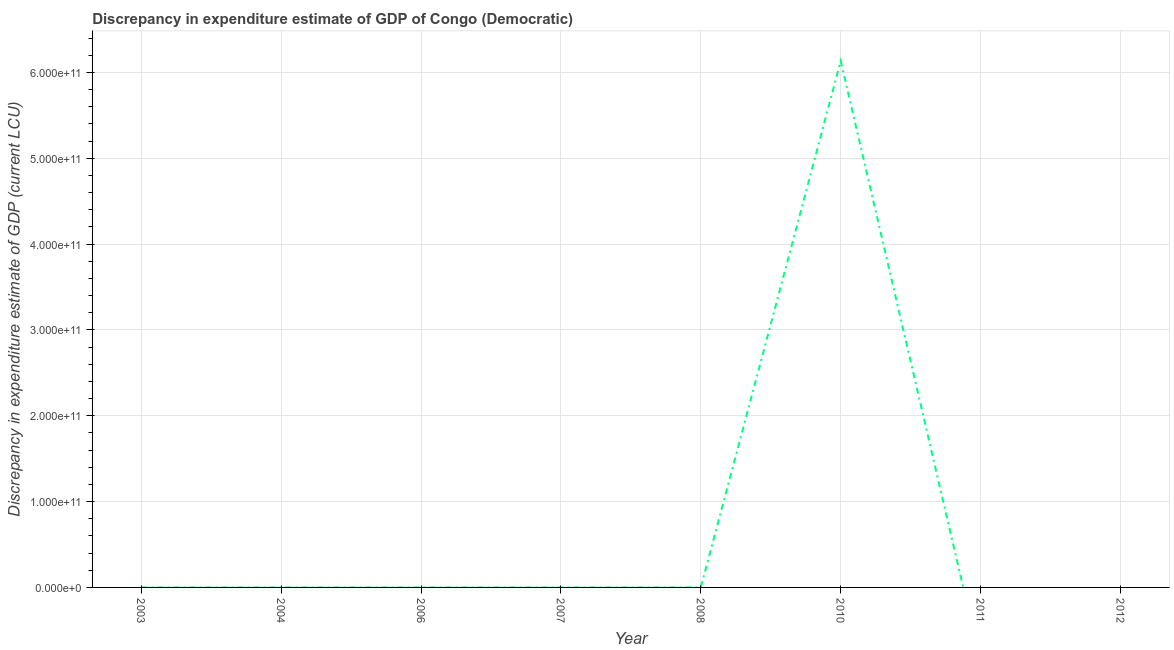What is the discrepancy in expenditure estimate of gdp in 2006?
Your response must be concise. 0. Across all years, what is the maximum discrepancy in expenditure estimate of gdp?
Keep it short and to the point. 6.13e+11. What is the sum of the discrepancy in expenditure estimate of gdp?
Your answer should be compact. 6.13e+11. What is the difference between the discrepancy in expenditure estimate of gdp in 2008 and 2010?
Provide a short and direct response. -6.13e+11. What is the average discrepancy in expenditure estimate of gdp per year?
Your answer should be very brief. 7.67e+1. What is the median discrepancy in expenditure estimate of gdp?
Keep it short and to the point. 3e-5. In how many years, is the discrepancy in expenditure estimate of gdp greater than 340000000000 LCU?
Keep it short and to the point. 1. What is the ratio of the discrepancy in expenditure estimate of gdp in 2007 to that in 2008?
Offer a terse response. 1. What is the difference between the highest and the second highest discrepancy in expenditure estimate of gdp?
Your answer should be compact. 6.13e+11. What is the difference between the highest and the lowest discrepancy in expenditure estimate of gdp?
Offer a terse response. 6.13e+11. How many lines are there?
Offer a very short reply. 1. How many years are there in the graph?
Your answer should be compact. 8. What is the difference between two consecutive major ticks on the Y-axis?
Provide a succinct answer. 1.00e+11. Are the values on the major ticks of Y-axis written in scientific E-notation?
Offer a very short reply. Yes. Does the graph contain any zero values?
Your answer should be very brief. Yes. Does the graph contain grids?
Your answer should be very brief. Yes. What is the title of the graph?
Your response must be concise. Discrepancy in expenditure estimate of GDP of Congo (Democratic). What is the label or title of the Y-axis?
Your answer should be very brief. Discrepancy in expenditure estimate of GDP (current LCU). What is the Discrepancy in expenditure estimate of GDP (current LCU) of 2003?
Keep it short and to the point. 6e-5. What is the Discrepancy in expenditure estimate of GDP (current LCU) in 2007?
Provide a succinct answer. 10. What is the Discrepancy in expenditure estimate of GDP (current LCU) in 2008?
Your answer should be very brief. 10. What is the Discrepancy in expenditure estimate of GDP (current LCU) in 2010?
Provide a short and direct response. 6.13e+11. What is the Discrepancy in expenditure estimate of GDP (current LCU) in 2011?
Make the answer very short. 0. What is the Discrepancy in expenditure estimate of GDP (current LCU) of 2012?
Provide a succinct answer. 0. What is the difference between the Discrepancy in expenditure estimate of GDP (current LCU) in 2003 and 2007?
Your response must be concise. -10. What is the difference between the Discrepancy in expenditure estimate of GDP (current LCU) in 2003 and 2008?
Make the answer very short. -10. What is the difference between the Discrepancy in expenditure estimate of GDP (current LCU) in 2003 and 2010?
Give a very brief answer. -6.13e+11. What is the difference between the Discrepancy in expenditure estimate of GDP (current LCU) in 2007 and 2008?
Make the answer very short. 0. What is the difference between the Discrepancy in expenditure estimate of GDP (current LCU) in 2007 and 2010?
Ensure brevity in your answer.  -6.13e+11. What is the difference between the Discrepancy in expenditure estimate of GDP (current LCU) in 2008 and 2010?
Your response must be concise. -6.13e+11. What is the ratio of the Discrepancy in expenditure estimate of GDP (current LCU) in 2003 to that in 2010?
Ensure brevity in your answer.  0. What is the ratio of the Discrepancy in expenditure estimate of GDP (current LCU) in 2007 to that in 2008?
Keep it short and to the point. 1. 